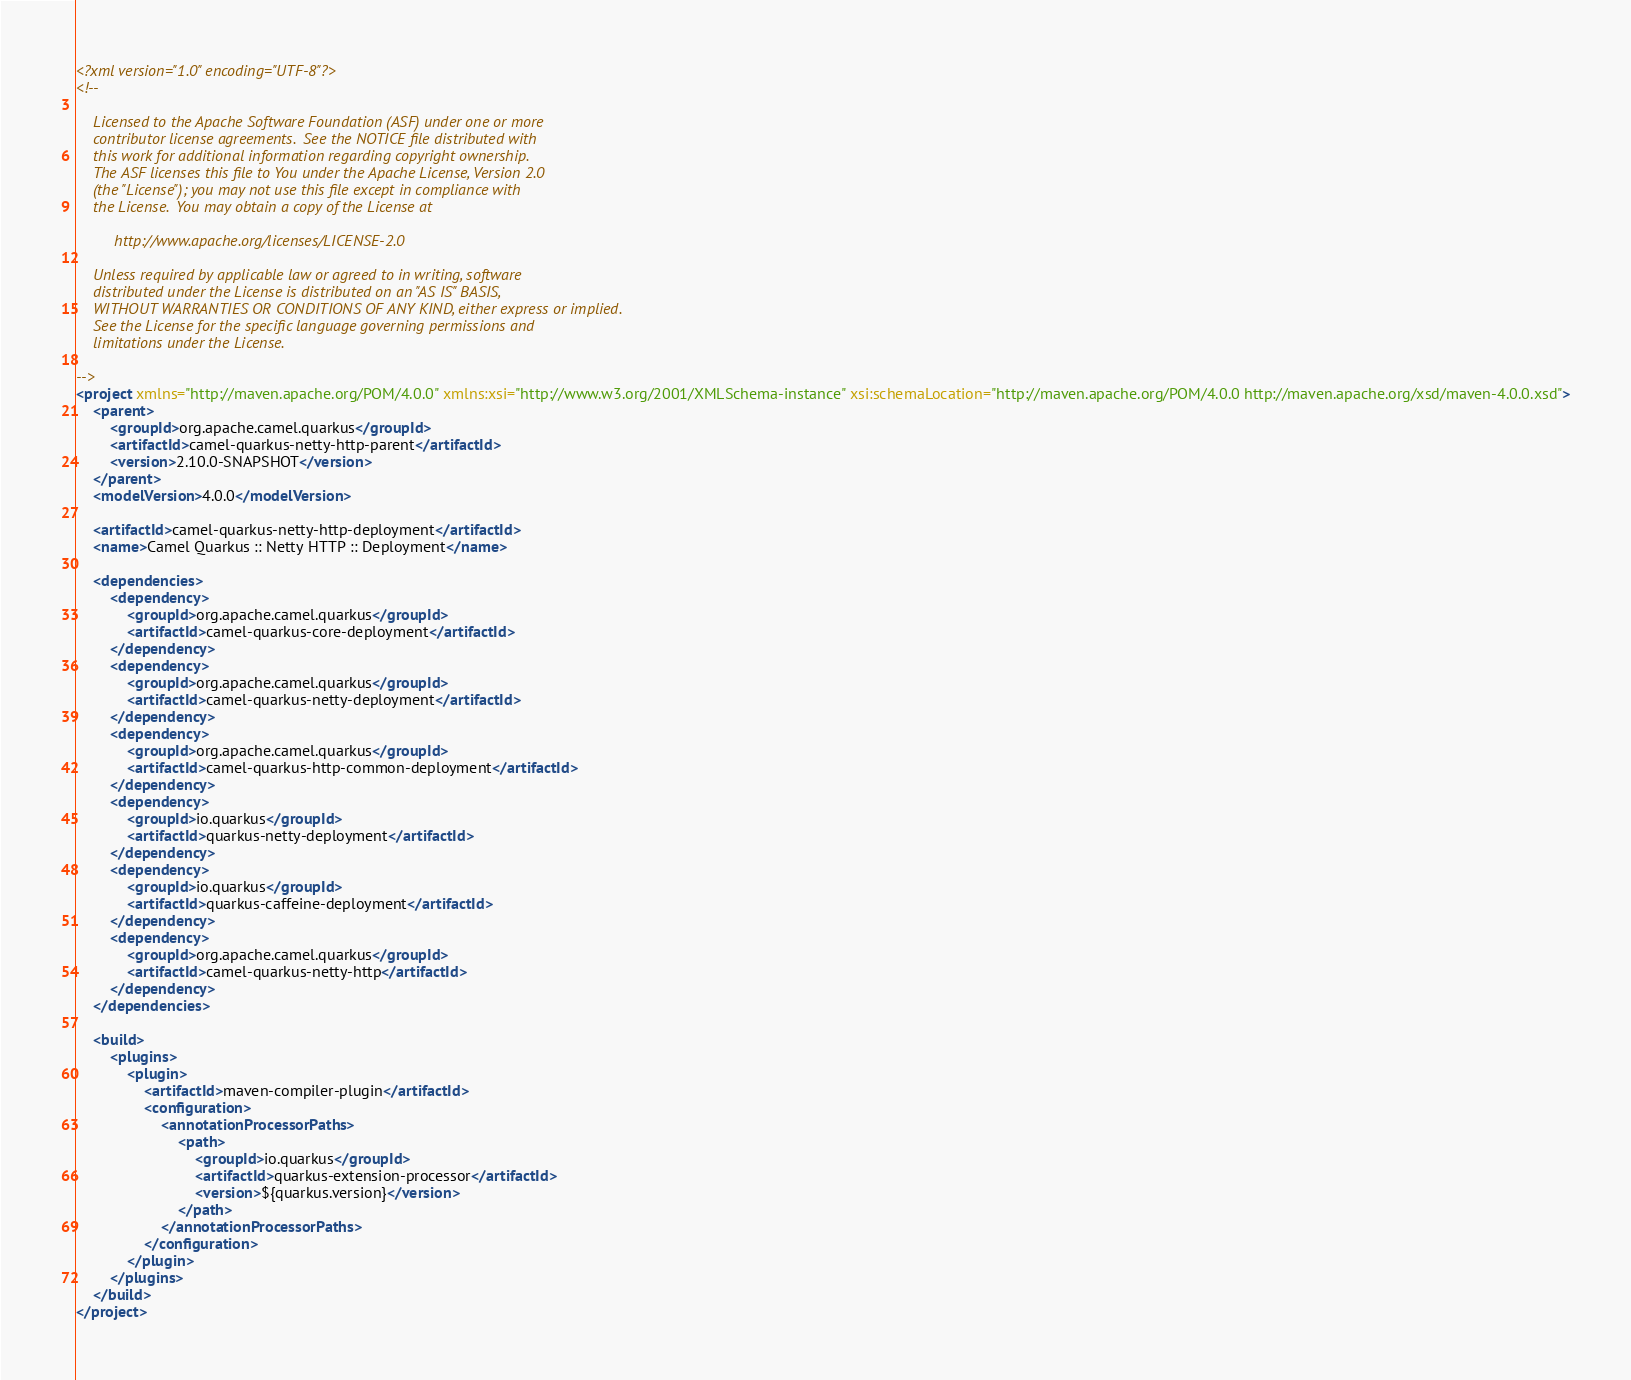<code> <loc_0><loc_0><loc_500><loc_500><_XML_><?xml version="1.0" encoding="UTF-8"?>
<!--

    Licensed to the Apache Software Foundation (ASF) under one or more
    contributor license agreements.  See the NOTICE file distributed with
    this work for additional information regarding copyright ownership.
    The ASF licenses this file to You under the Apache License, Version 2.0
    (the "License"); you may not use this file except in compliance with
    the License.  You may obtain a copy of the License at

         http://www.apache.org/licenses/LICENSE-2.0

    Unless required by applicable law or agreed to in writing, software
    distributed under the License is distributed on an "AS IS" BASIS,
    WITHOUT WARRANTIES OR CONDITIONS OF ANY KIND, either express or implied.
    See the License for the specific language governing permissions and
    limitations under the License.

-->
<project xmlns="http://maven.apache.org/POM/4.0.0" xmlns:xsi="http://www.w3.org/2001/XMLSchema-instance" xsi:schemaLocation="http://maven.apache.org/POM/4.0.0 http://maven.apache.org/xsd/maven-4.0.0.xsd">
    <parent>
        <groupId>org.apache.camel.quarkus</groupId>
        <artifactId>camel-quarkus-netty-http-parent</artifactId>
        <version>2.10.0-SNAPSHOT</version>
    </parent>
    <modelVersion>4.0.0</modelVersion>

    <artifactId>camel-quarkus-netty-http-deployment</artifactId>
    <name>Camel Quarkus :: Netty HTTP :: Deployment</name>

    <dependencies>
        <dependency>
            <groupId>org.apache.camel.quarkus</groupId>
            <artifactId>camel-quarkus-core-deployment</artifactId>
        </dependency>
        <dependency>
            <groupId>org.apache.camel.quarkus</groupId>
            <artifactId>camel-quarkus-netty-deployment</artifactId>
        </dependency>
        <dependency>
            <groupId>org.apache.camel.quarkus</groupId>
            <artifactId>camel-quarkus-http-common-deployment</artifactId>
        </dependency>
        <dependency>
            <groupId>io.quarkus</groupId>
            <artifactId>quarkus-netty-deployment</artifactId>
        </dependency>
        <dependency>
            <groupId>io.quarkus</groupId>
            <artifactId>quarkus-caffeine-deployment</artifactId>
        </dependency>
        <dependency>
            <groupId>org.apache.camel.quarkus</groupId>
            <artifactId>camel-quarkus-netty-http</artifactId>
        </dependency>
    </dependencies>

    <build>
        <plugins>
            <plugin>
                <artifactId>maven-compiler-plugin</artifactId>
                <configuration>
                    <annotationProcessorPaths>
                        <path>
                            <groupId>io.quarkus</groupId>
                            <artifactId>quarkus-extension-processor</artifactId>
                            <version>${quarkus.version}</version>
                        </path>
                    </annotationProcessorPaths>
                </configuration>
            </plugin>
        </plugins>
    </build>
</project>
</code> 